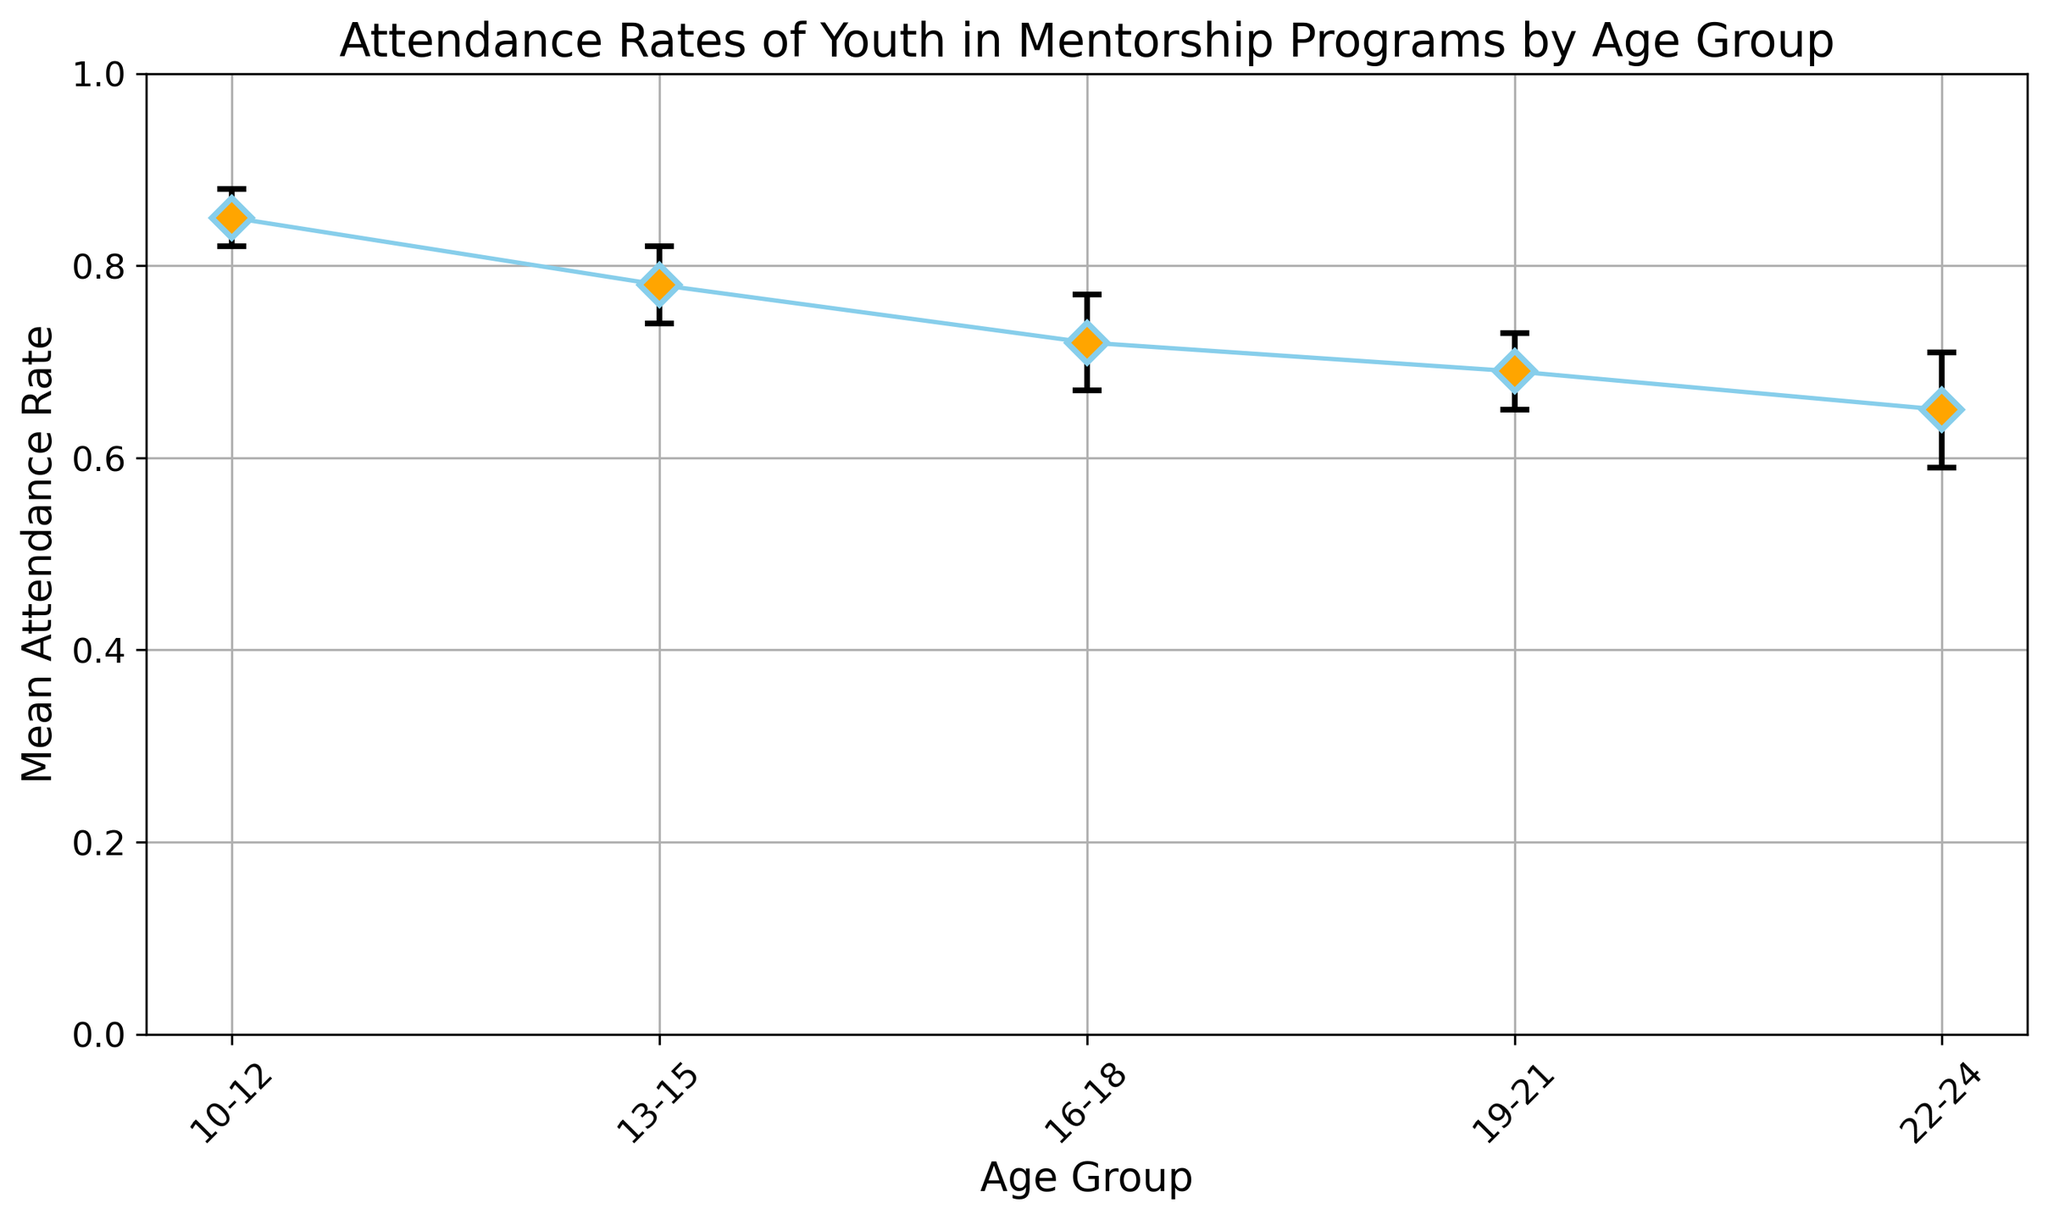Which age group has the highest mean attendance rate? Start by looking at the y-axis values corresponding to each age group. Identify the highest value, which is 0.85, and see that it aligns with the 10-12 age group.
Answer: 10-12 Which age group has the lowest mean attendance rate? Examine the y-axis values and find the smallest value, 0.65, associated with the 22-24 age group.
Answer: 22-24 What is the difference in mean attendance rate between the 10-12 and 22-24 age groups? Subtract the mean attendance rate of the 22-24 age group (0.65) from that of the 10-12 age group (0.85): 0.85 - 0.65 = 0.20.
Answer: 0.20 Which age group has the widest confidence interval? Determine the width of each confidence interval by subtracting the lower bound from the upper bound. The widest interval (0.71 - 0.59 = 0.12) is for the 22-24 age group.
Answer: 22-24 What is the average mean attendance rate for all age groups? Add the mean attendance rates (0.85 + 0.78 + 0.72 + 0.69 + 0.65) and divide by the number of age groups (5). The sum is 3.69, so the average is 3.69 / 5 = 0.738.
Answer: 0.738 Which age group has the smallest standard deviation? Identify the smallest value in the 'std_dev' column, which is 0.04 for the 10-12 age group.
Answer: 10-12 By how much does the mean attendance rate decrease from the 13-15 age group to the 16-18 age group? Subtract the mean attendance rate of the 16-18 age group (0.72) from that of the 13-15 age group (0.78): 0.78 - 0.72 = 0.06.
Answer: 0.06 How does the mean attendance rate change as the age group increases? Observe the trend in the mean attendance rates: they generally decrease as the age group increases from 10-12 to 22-24.
Answer: It decreases Which age group has a mean attendance rate closest to 0.70? Compare all mean attendance rates to 0.70 and find the closest, which is 0.69 for the 19-21 age group.
Answer: 19-21 Which age group’s confidence interval includes the mean attendance rate of the 19-21 age group? Identify the confidence intervals and check if 0.69 (mean for 19-21) falls within them. Only the 19-21 age group itself includes 0.69 in its interval (0.65 to 0.73).
Answer: 19-21 